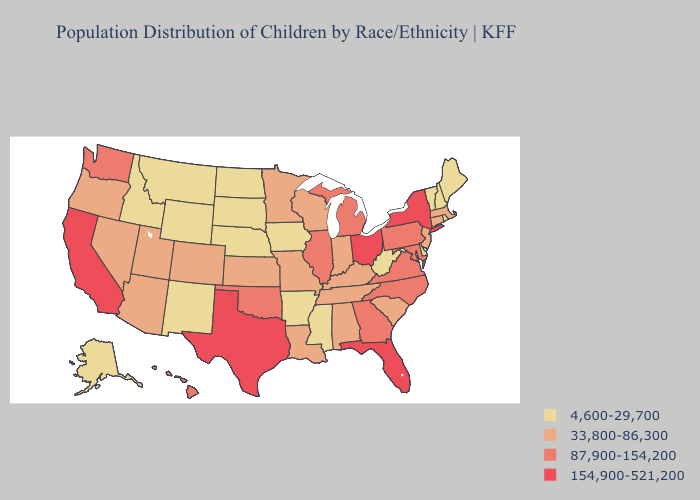Does Kansas have the same value as South Dakota?
Give a very brief answer. No. Does New York have the lowest value in the Northeast?
Concise answer only. No. Name the states that have a value in the range 33,800-86,300?
Answer briefly. Alabama, Arizona, Colorado, Connecticut, Indiana, Kansas, Kentucky, Louisiana, Massachusetts, Minnesota, Missouri, Nevada, New Jersey, Oregon, South Carolina, Tennessee, Utah, Wisconsin. Name the states that have a value in the range 33,800-86,300?
Answer briefly. Alabama, Arizona, Colorado, Connecticut, Indiana, Kansas, Kentucky, Louisiana, Massachusetts, Minnesota, Missouri, Nevada, New Jersey, Oregon, South Carolina, Tennessee, Utah, Wisconsin. Does the map have missing data?
Short answer required. No. What is the value of Indiana?
Be succinct. 33,800-86,300. What is the value of New Hampshire?
Write a very short answer. 4,600-29,700. Which states hav the highest value in the MidWest?
Answer briefly. Ohio. Name the states that have a value in the range 87,900-154,200?
Write a very short answer. Georgia, Hawaii, Illinois, Maryland, Michigan, North Carolina, Oklahoma, Pennsylvania, Virginia, Washington. Name the states that have a value in the range 154,900-521,200?
Write a very short answer. California, Florida, New York, Ohio, Texas. Name the states that have a value in the range 154,900-521,200?
Give a very brief answer. California, Florida, New York, Ohio, Texas. Does Massachusetts have the lowest value in the Northeast?
Write a very short answer. No. Name the states that have a value in the range 4,600-29,700?
Be succinct. Alaska, Arkansas, Delaware, Idaho, Iowa, Maine, Mississippi, Montana, Nebraska, New Hampshire, New Mexico, North Dakota, Rhode Island, South Dakota, Vermont, West Virginia, Wyoming. What is the highest value in the South ?
Short answer required. 154,900-521,200. Name the states that have a value in the range 33,800-86,300?
Write a very short answer. Alabama, Arizona, Colorado, Connecticut, Indiana, Kansas, Kentucky, Louisiana, Massachusetts, Minnesota, Missouri, Nevada, New Jersey, Oregon, South Carolina, Tennessee, Utah, Wisconsin. 